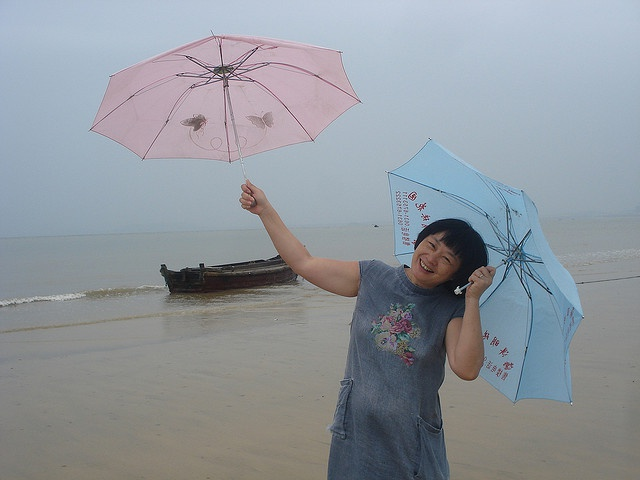Describe the objects in this image and their specific colors. I can see people in darkgray, gray, black, and darkblue tones, umbrella in darkgray, pink, and lightgray tones, umbrella in darkgray, gray, and lightblue tones, boat in darkgray, black, and gray tones, and boat in blue, darkgray, black, and darkblue tones in this image. 